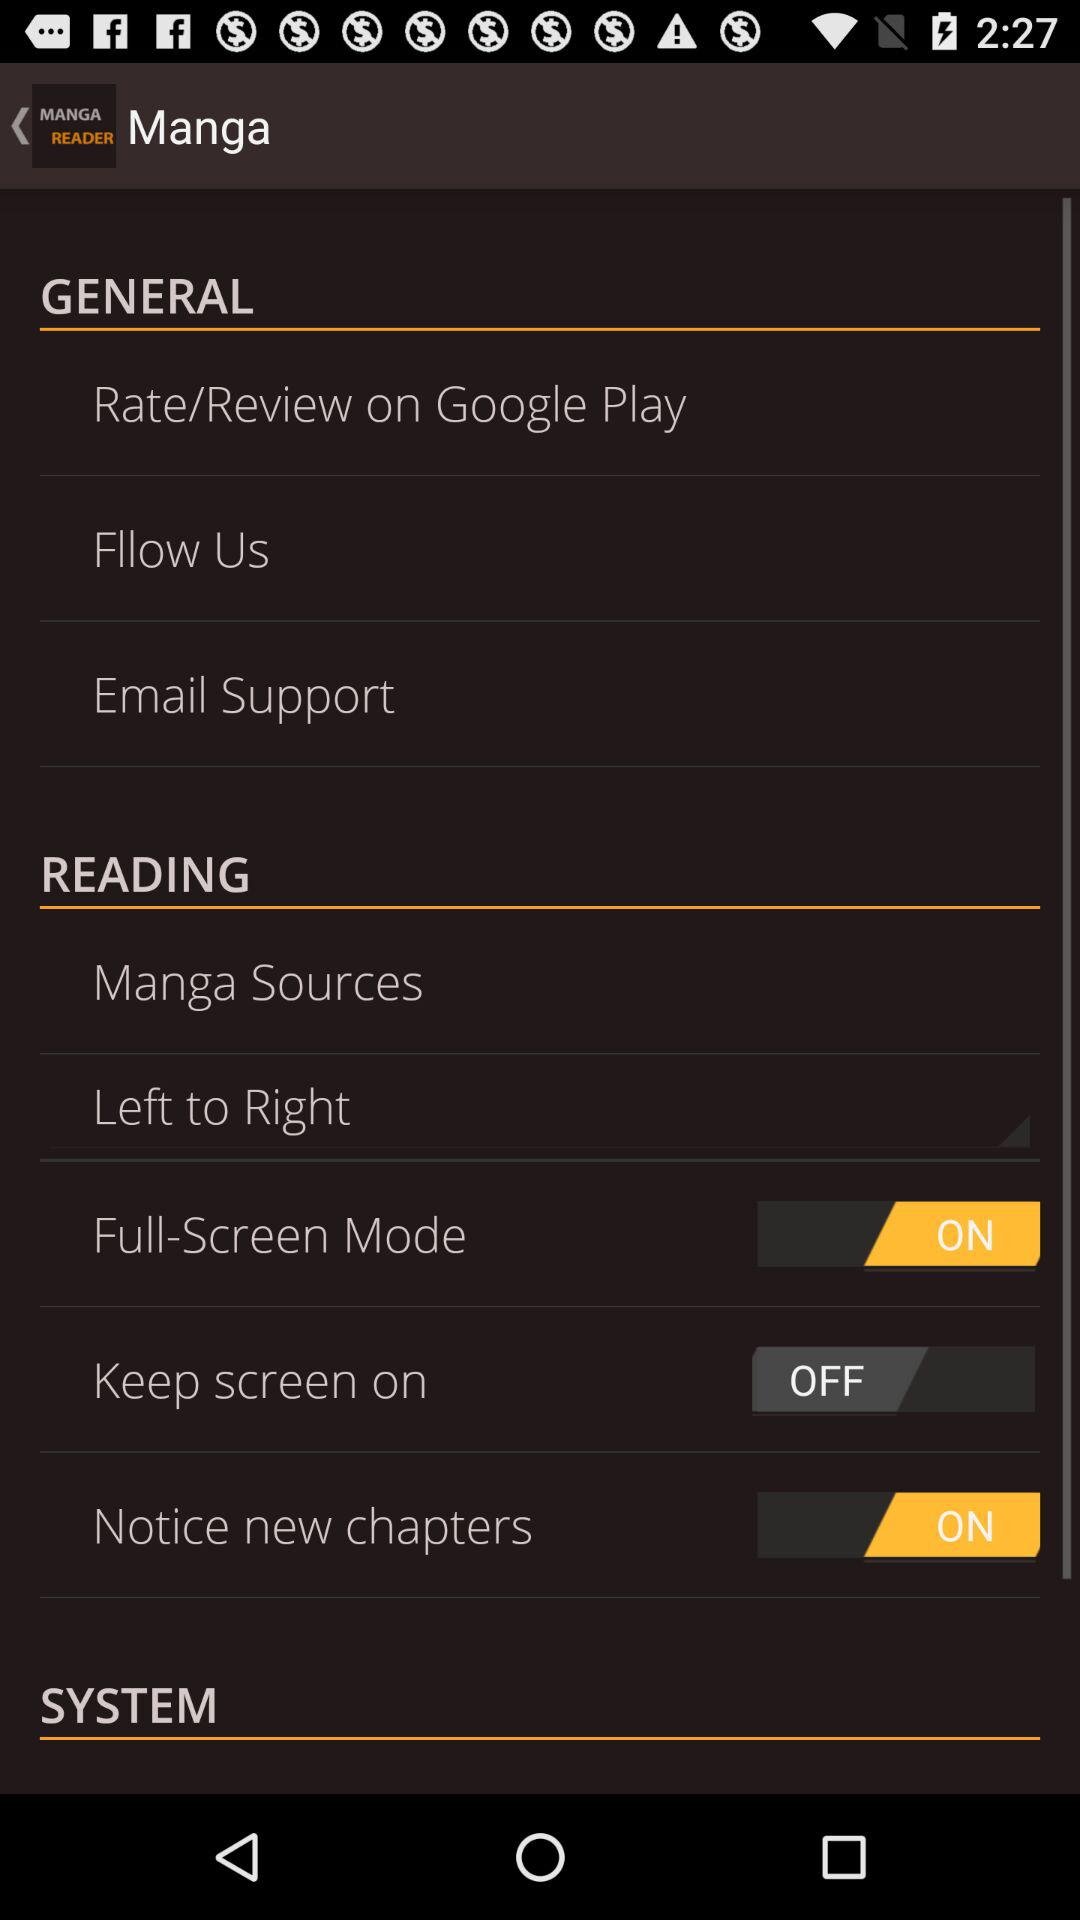What is the current status of "Notice new chapters"? The current status is "on". 